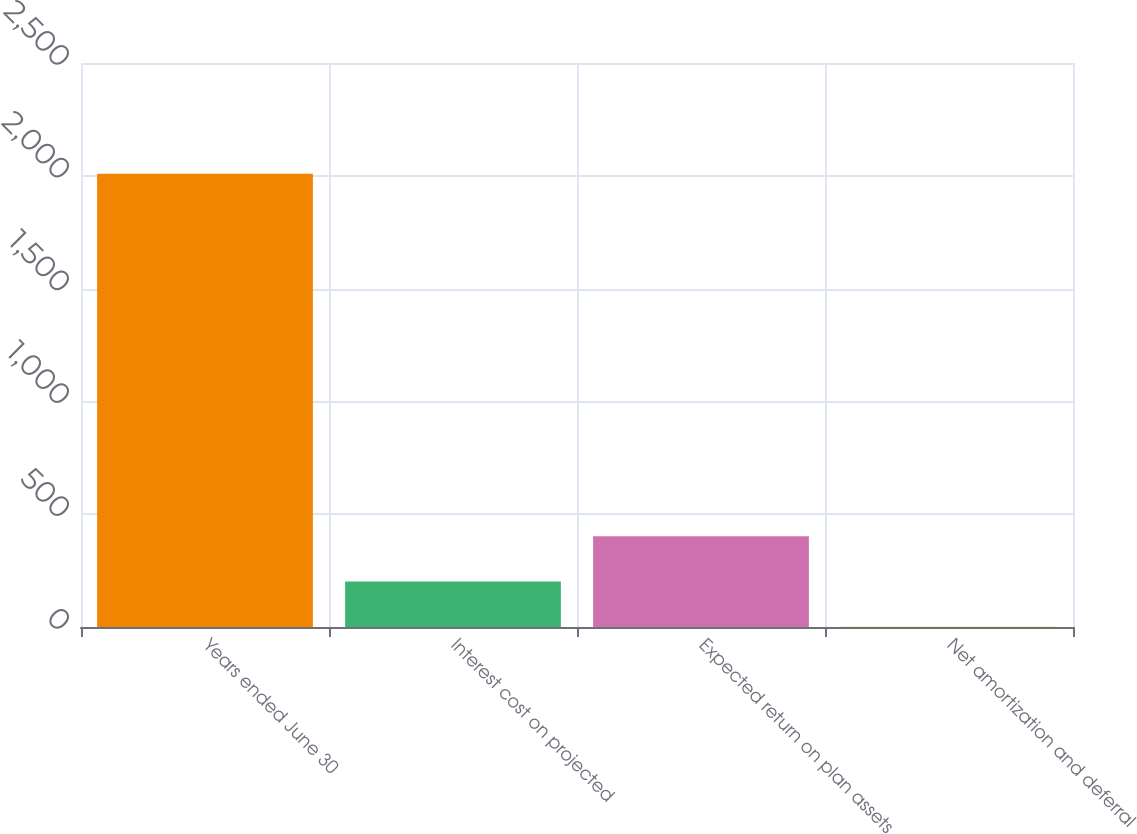<chart> <loc_0><loc_0><loc_500><loc_500><bar_chart><fcel>Years ended June 30<fcel>Interest cost on projected<fcel>Expected return on plan assets<fcel>Net amortization and deferral<nl><fcel>2009<fcel>201.98<fcel>402.76<fcel>1.2<nl></chart> 